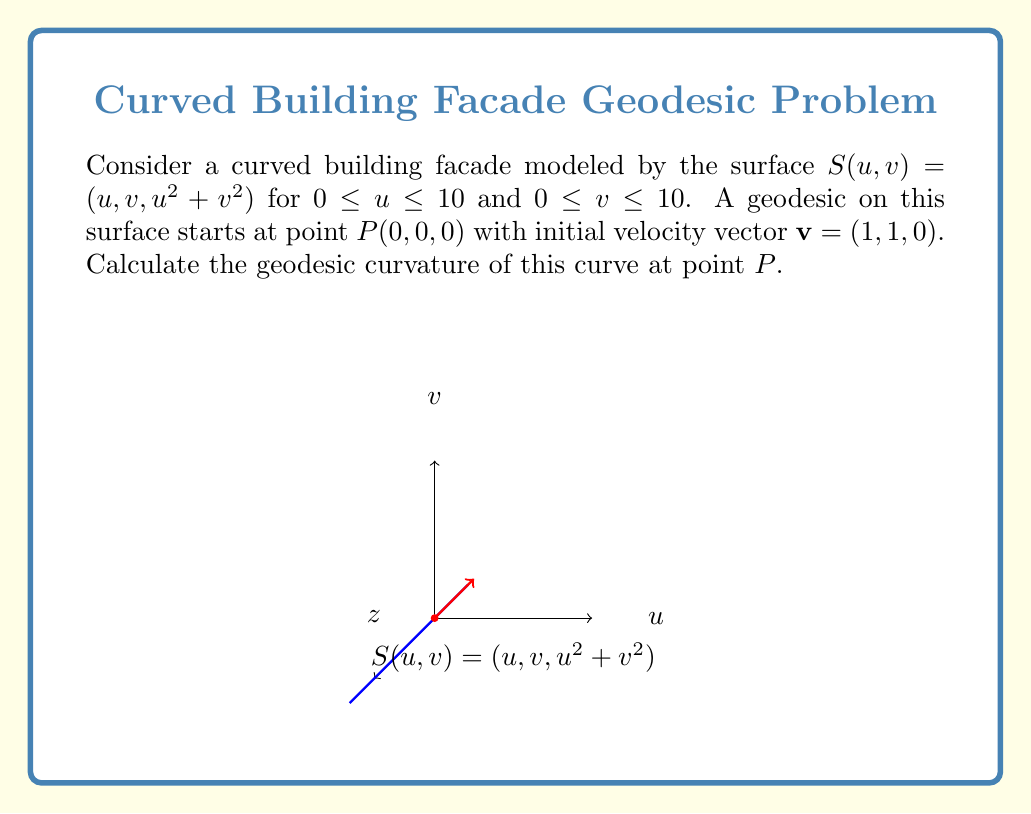Can you answer this question? To solve this problem, we'll follow these steps:

1) First, we need to calculate the metric tensor $g_{ij}$ of the surface. The surface is given by $S(u,v) = (u, v, u^2 + v^2)$. Let's calculate the partial derivatives:

   $S_u = (1, 0, 2u)$
   $S_v = (0, 1, 2v)$

   The metric tensor is:
   $$g_{ij} = \begin{pmatrix}
   1 + 4u^2 & 4uv \\
   4uv & 1 + 4v^2
   \end{pmatrix}$$

2) At point $P(0,0,0)$, the metric tensor simplifies to:
   $$g_{ij}(P) = \begin{pmatrix}
   1 & 0 \\
   0 & 1
   \end{pmatrix}$$

3) The geodesic curvature $\kappa_g$ is given by:
   $$\kappa_g = \frac{|\det(S_u, S_v, S_{uu})|}{|S_u \times S_v|^2}$$

   where $S_{uu}$ is the second derivative of $S$ with respect to $u$.

4) Calculate $S_{uu}$:
   $S_{uu} = (0, 0, 2)$

5) Calculate $|S_u \times S_v|$:
   $S_u \times S_v = (-2v, 2u, 1)$
   $|S_u \times S_v| = \sqrt{4v^2 + 4u^2 + 1}$

6) At point $P(0,0,0)$:
   $|S_u \times S_v|_P = 1$

7) Calculate $\det(S_u, S_v, S_{uu})$ at $P$:
   $$\det\begin{pmatrix}
   1 & 0 & 0 \\
   0 & 1 & 0 \\
   0 & 0 & 2
   \end{pmatrix} = 2$$

8) Therefore, the geodesic curvature at point $P$ is:
   $$\kappa_g = \frac{|2|}{1^2} = 2$$
Answer: $\kappa_g = 2$ 